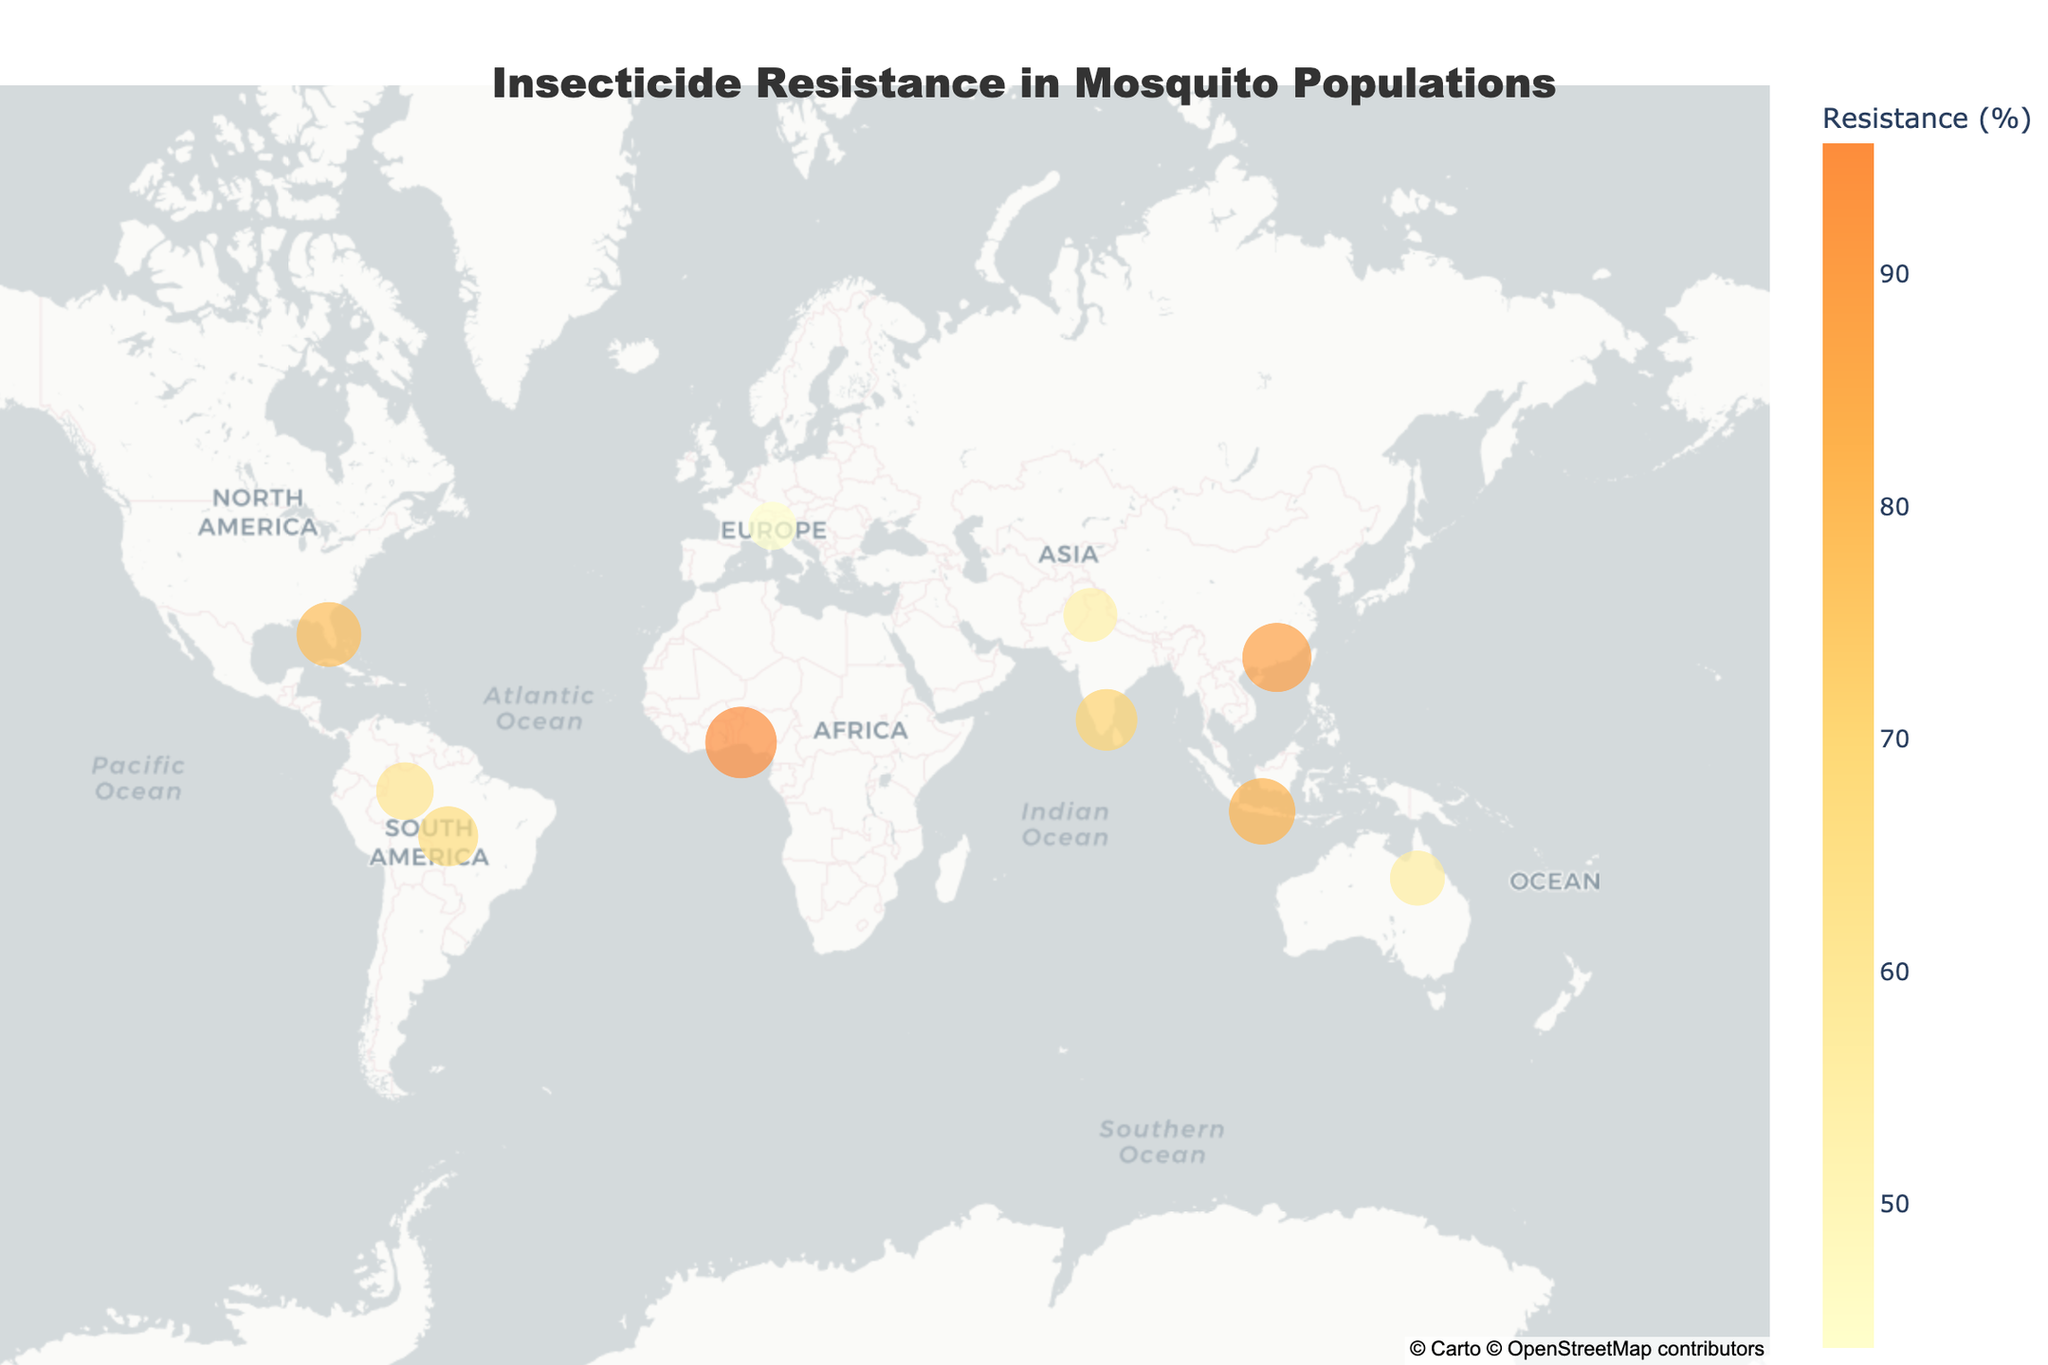Which region shows the highest resistance percentage? By looking at the geographic plot, identify the region with the largest circle and the darkest color shade, indicating the highest resistance percentage.
Answer: Lagos What mosquito species is found in the region with the lowest resistance percentage? Locate the smallest circle on the map, representing the lowest resistance percentage, and check the corresponding mosquito species.
Answer: Culex pipiens What class of insecticide shows the highest resistance percentage in Aedes aegypti populations? Check the annotations or hover information for regions with Aedes aegypti populations and note the insecticide class with the highest resistance value among them.
Answer: Organophosphates Calculate the average resistance percentage across all regions. Sum all the resistance percentages given in the data table, and then divide by the number of regions (10). The calculation is (78.5 + 62.3 + 54.7 + 89.1 + 95.6 + 71.2 + 43.8 + 56.9 + 67.4 + 82.3) / 10.
Answer: 70.18 Compare the resistance percentages between Anopheles gambiae and Anopheles darlingi. Which one is higher and by how much? Check and subtract the resistance percentage of Anopheles darlingi from Anopheles gambiae. Anopheles gambiae has 95.6%, and Anopheles darlingi has 62.3%, so the difference is 95.6 - 62.3.
Answer: Anopheles gambiae, by 33.3 Are regions closer to the equator showing higher resistance percentages on average? Identify the locations near the equator and calculate their average resistance percentage. Compare this to the overall average resistance percentage calculated.
Answer: No, the average resistance near the equator is not significantly different How does insecticide resistance in Aedes aegypti compare between Florida and Java? Look at the resistance percentages for Aedes aegypti in Florida and Java from the plotted data or annotations and compare them.
Answer: Java is higher by 3.8% Which class of insecticides shows the broadest range of resistance percentages? Compare the maximum and minimum resistance percentages for each insecticide class, and determine which class has the largest difference.
Answer: Pyrethroids 